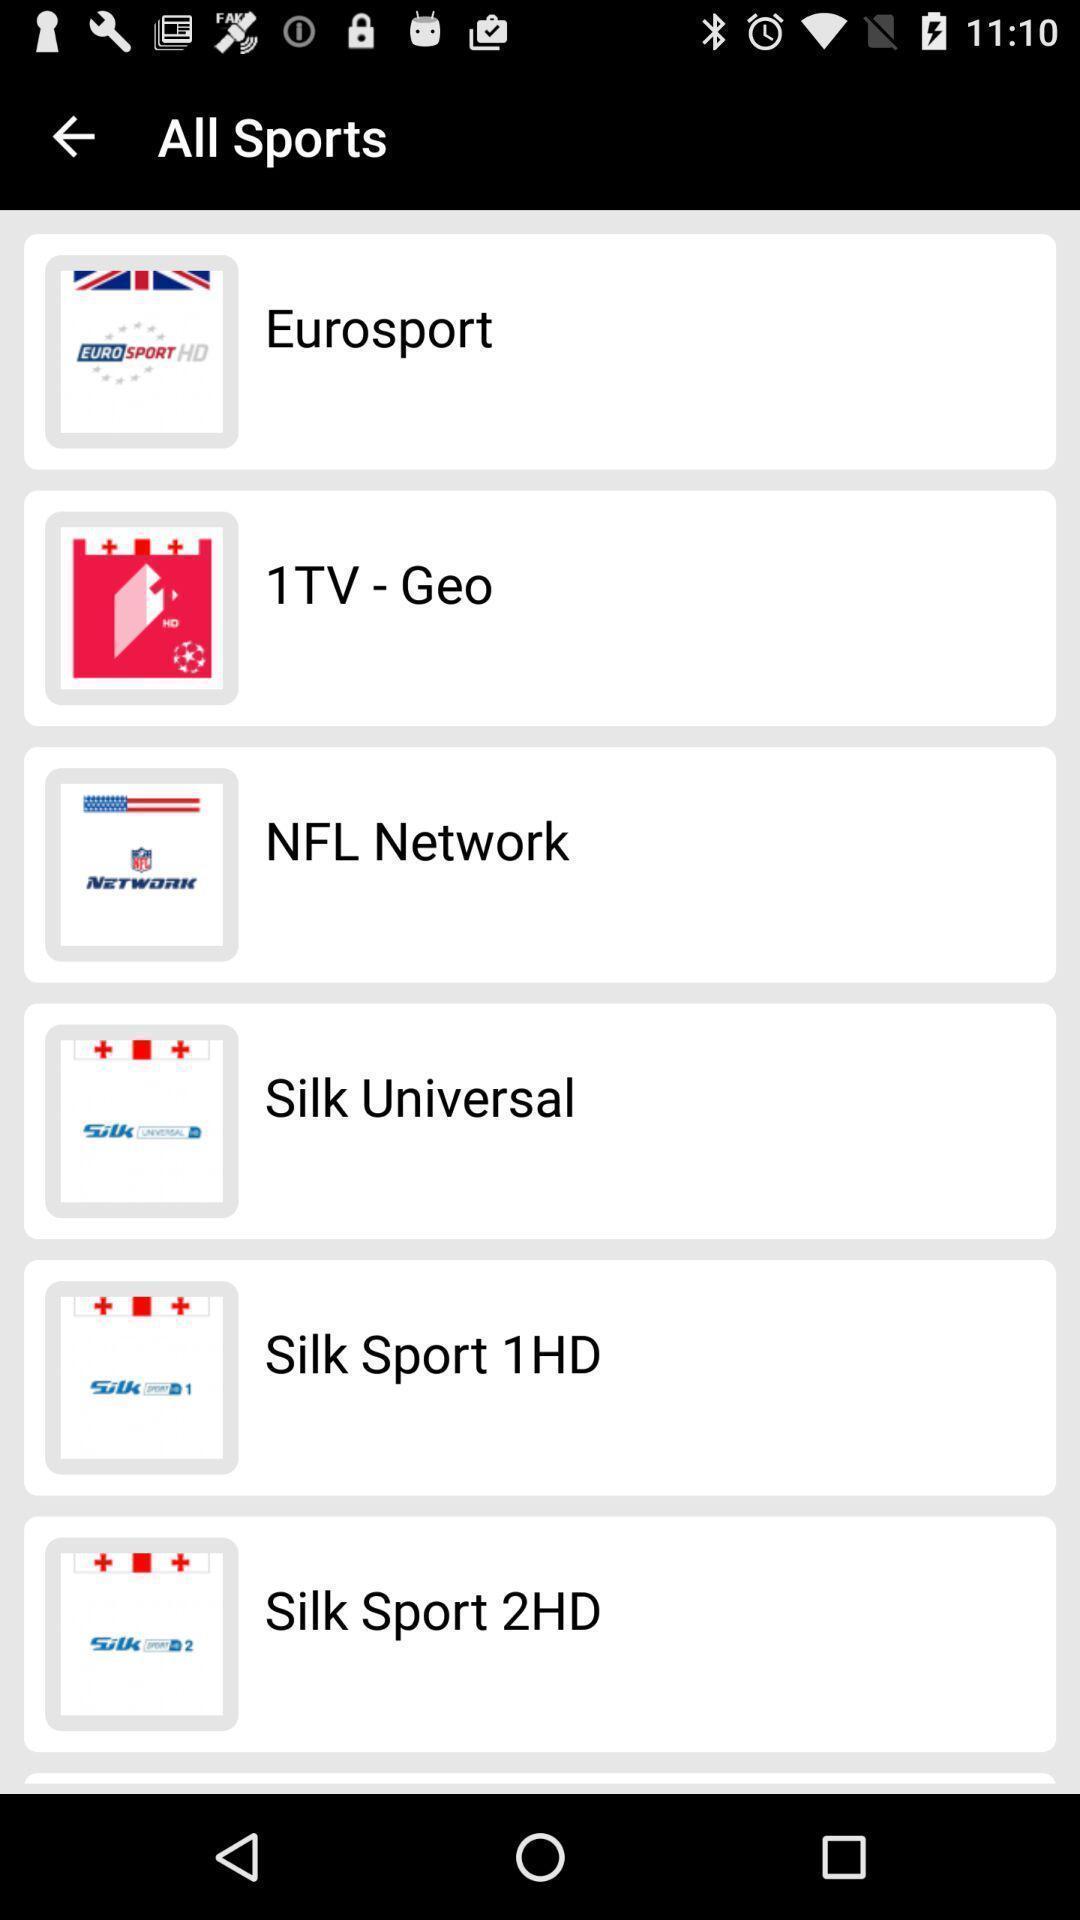Provide a detailed account of this screenshot. Screen displaying the list of sports. 